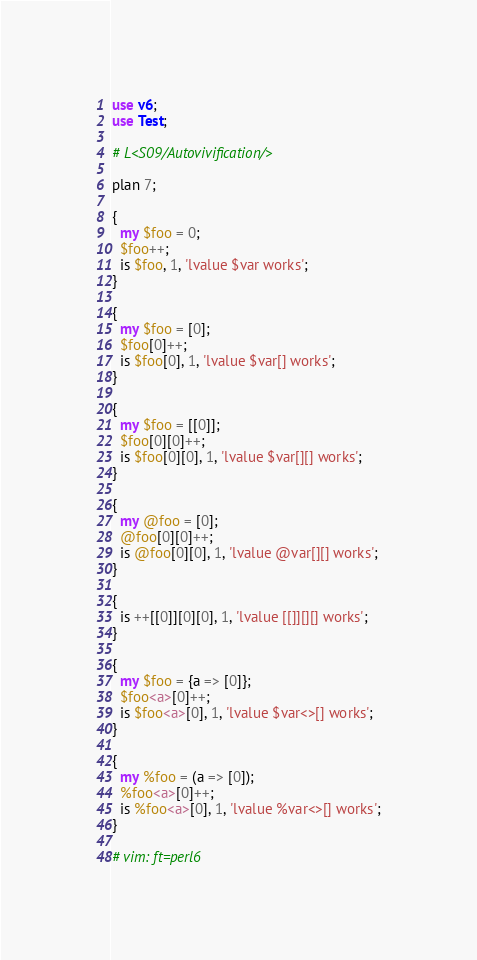<code> <loc_0><loc_0><loc_500><loc_500><_Perl_>use v6;
use Test;

# L<S09/Autovivification/>

plan 7;

{
  my $foo = 0;
  $foo++;
  is $foo, 1, 'lvalue $var works';
}

{
  my $foo = [0];
  $foo[0]++;
  is $foo[0], 1, 'lvalue $var[] works';
}

{
  my $foo = [[0]];
  $foo[0][0]++;
  is $foo[0][0], 1, 'lvalue $var[][] works';
}

{
  my @foo = [0];
  @foo[0][0]++;
  is @foo[0][0], 1, 'lvalue @var[][] works';
}

{
  is ++[[0]][0][0], 1, 'lvalue [[]][][] works';
}

{
  my $foo = {a => [0]};
  $foo<a>[0]++;
  is $foo<a>[0], 1, 'lvalue $var<>[] works';
}

{
  my %foo = (a => [0]);
  %foo<a>[0]++;
  is %foo<a>[0], 1, 'lvalue %var<>[] works';
}

# vim: ft=perl6
</code> 